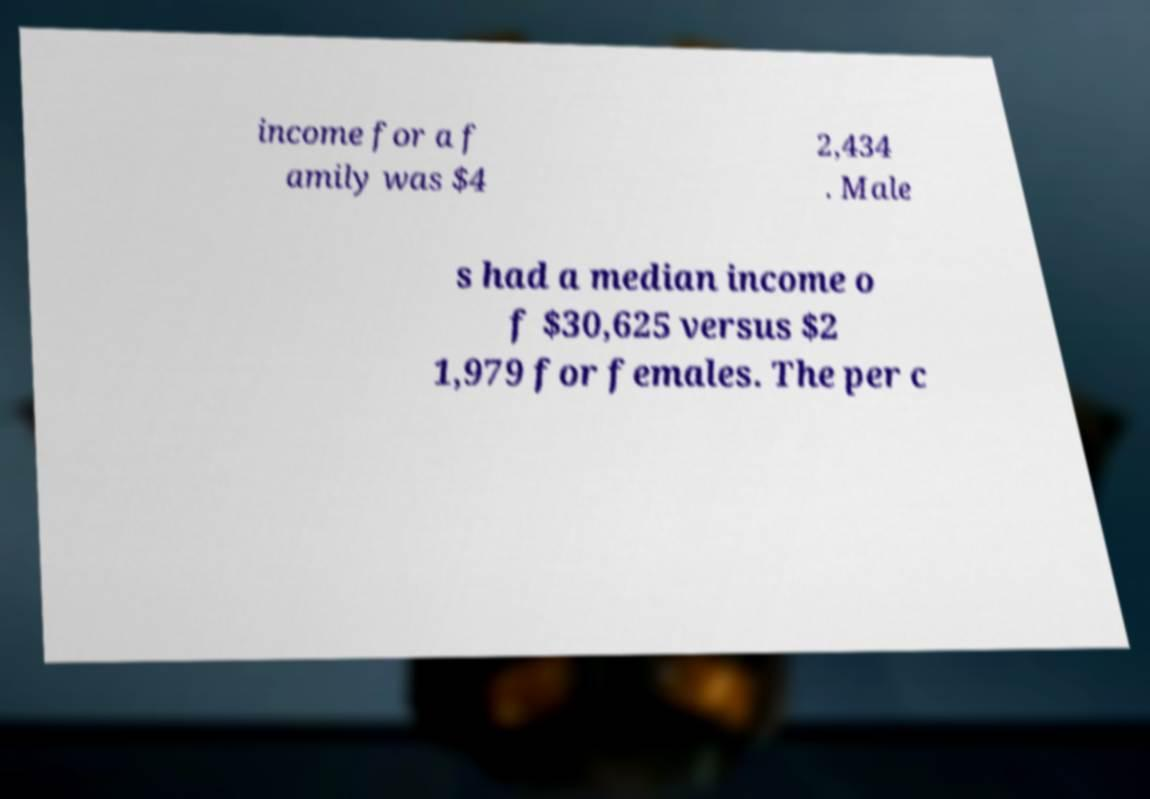Please identify and transcribe the text found in this image. income for a f amily was $4 2,434 . Male s had a median income o f $30,625 versus $2 1,979 for females. The per c 